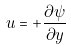<formula> <loc_0><loc_0><loc_500><loc_500>u = + \frac { \partial \psi } { \partial y }</formula> 